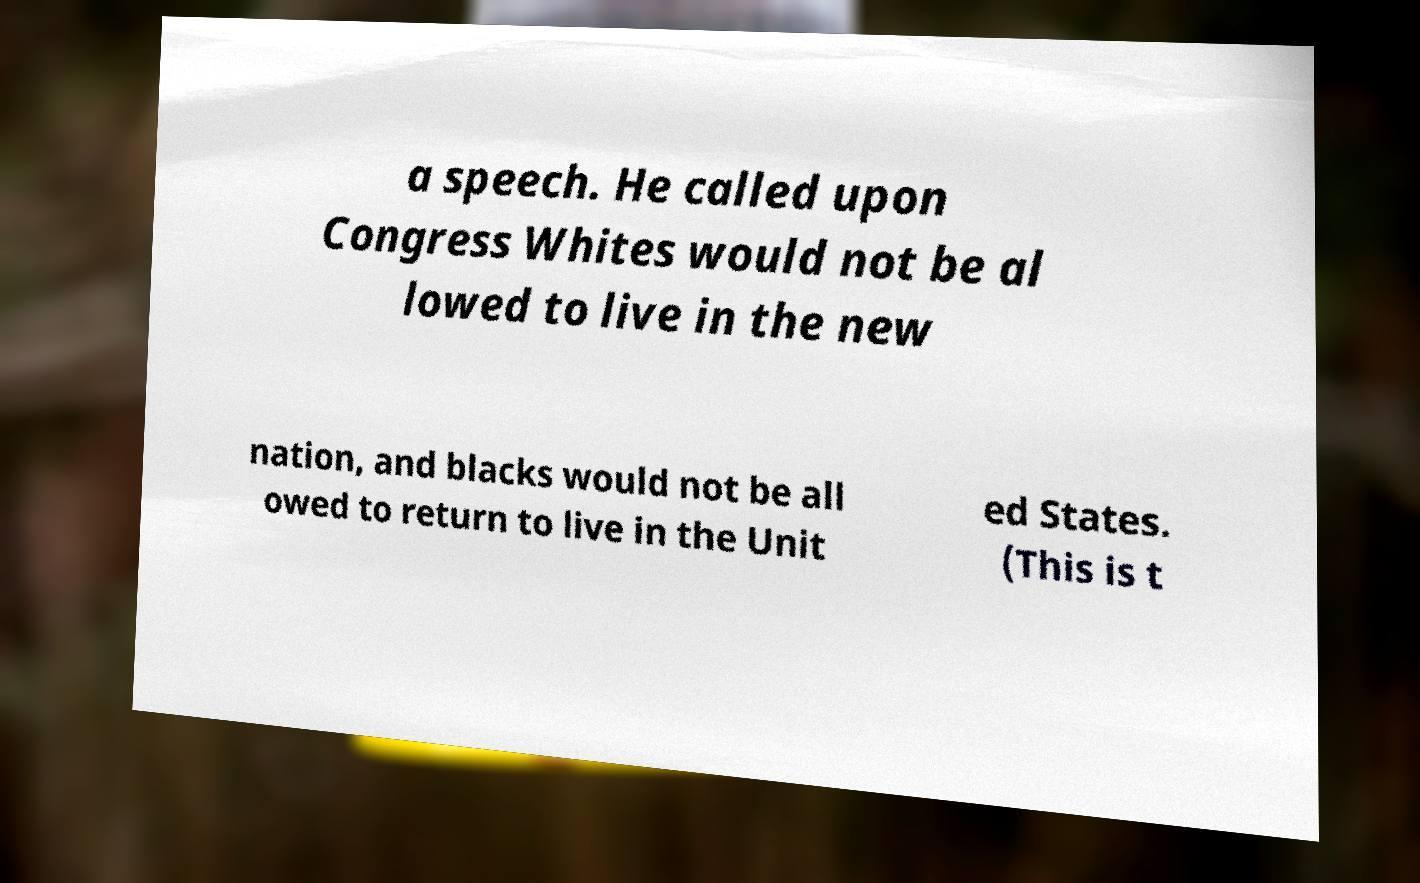What messages or text are displayed in this image? I need them in a readable, typed format. a speech. He called upon Congress Whites would not be al lowed to live in the new nation, and blacks would not be all owed to return to live in the Unit ed States. (This is t 